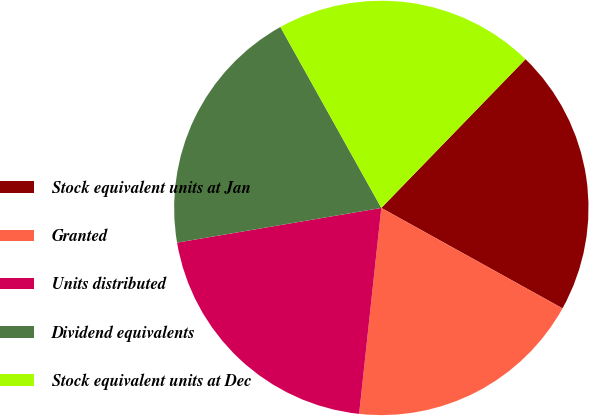Convert chart. <chart><loc_0><loc_0><loc_500><loc_500><pie_chart><fcel>Stock equivalent units at Jan<fcel>Granted<fcel>Units distributed<fcel>Dividend equivalents<fcel>Stock equivalent units at Dec<nl><fcel>20.8%<fcel>18.65%<fcel>20.61%<fcel>19.58%<fcel>20.35%<nl></chart> 